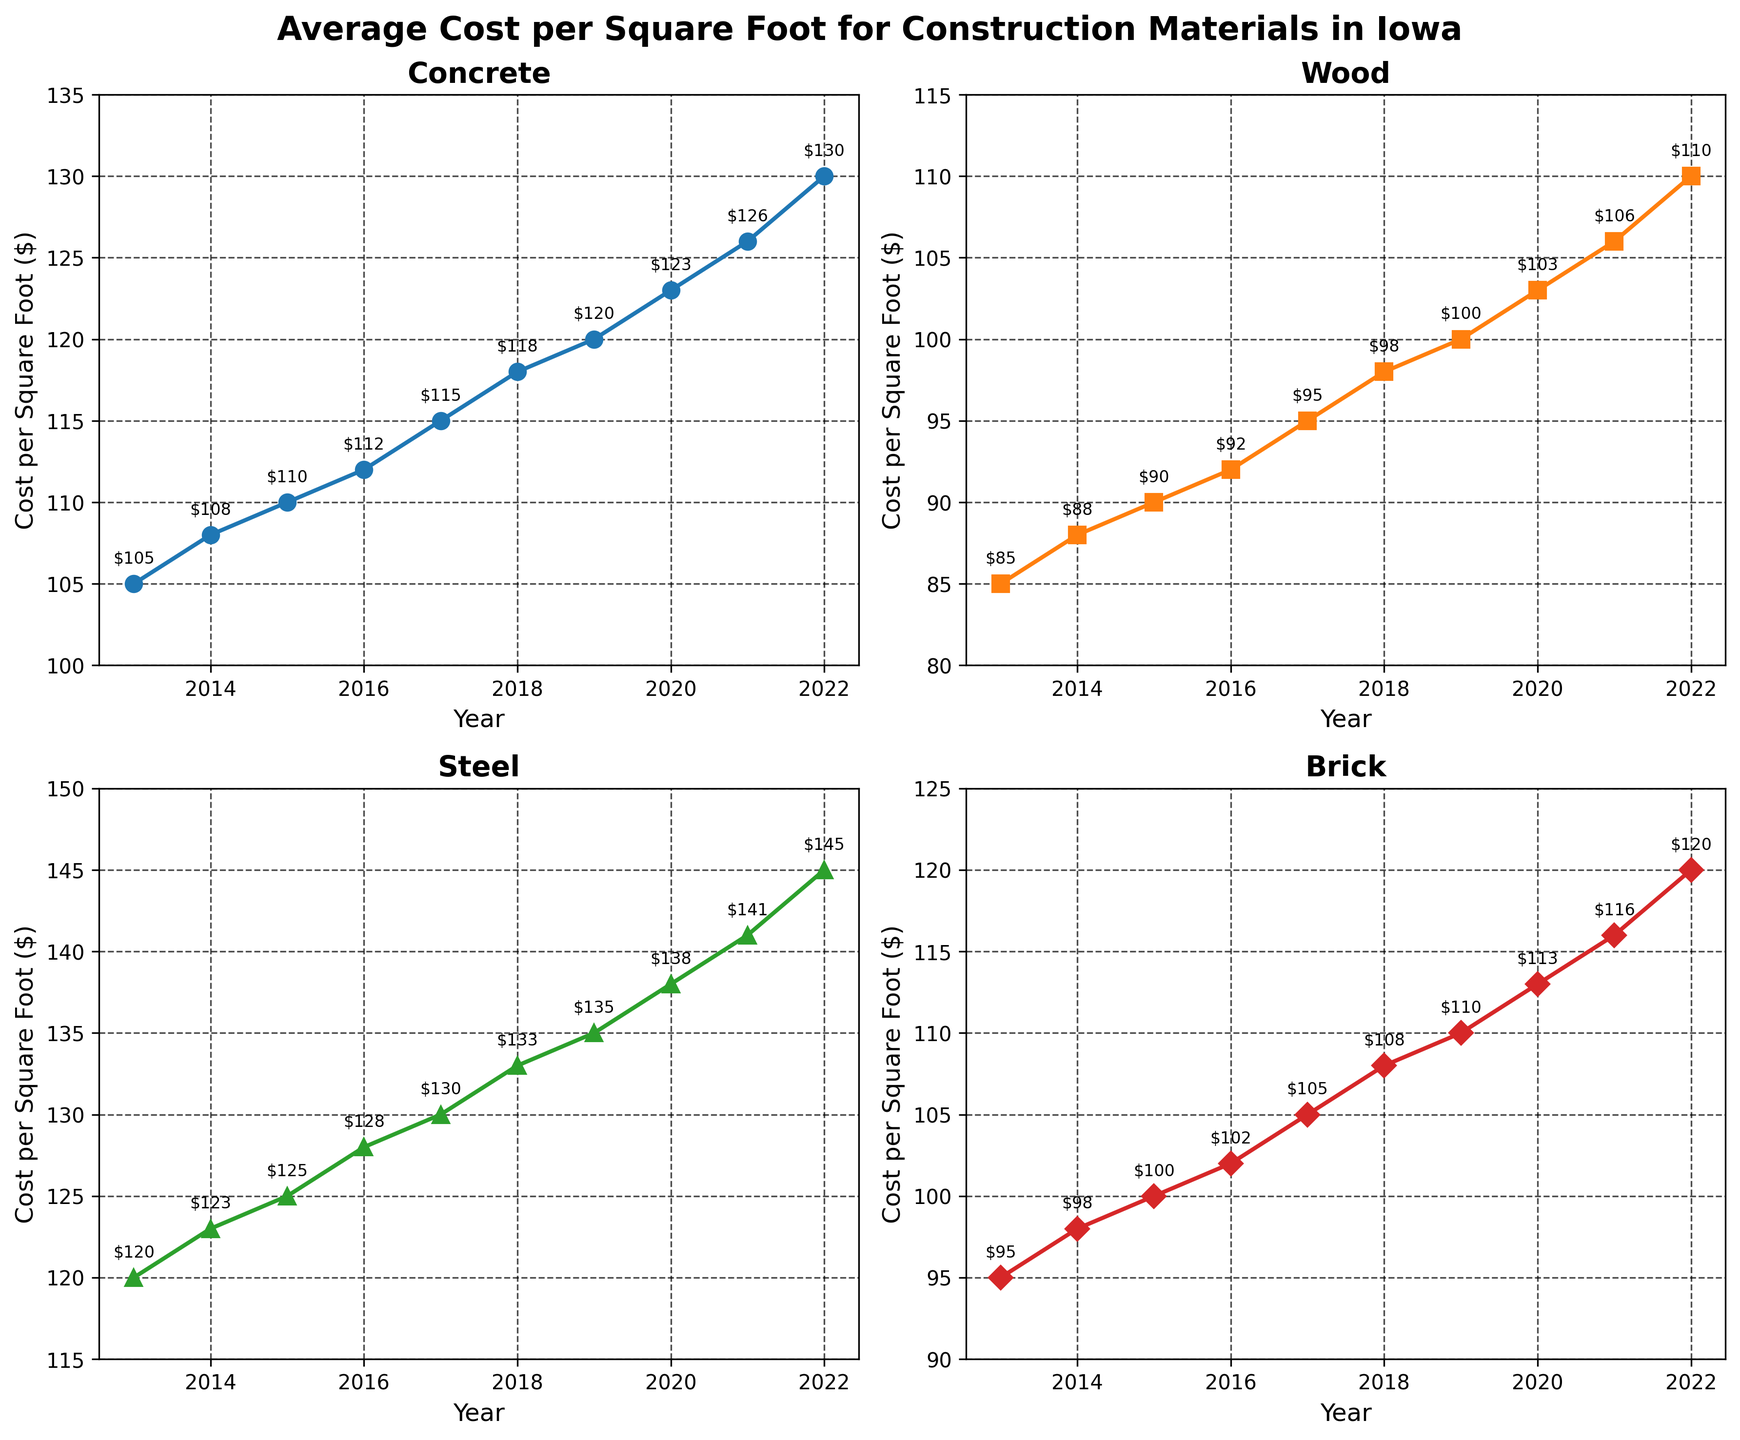Which material had the highest average cost per square foot in 2022? From the plot, compare the y-values for the year 2022 among all materials. Steel has the highest value.
Answer: Steel Which year saw the greatest increase in cost per square foot for Brick compared to the previous year? To find the year with the greatest increase, calculate the yearly differences for Brick: 2014: 3, 2015: 2, 2016: 2, 2017: 3, 2018: 3, 2019: 2, 2020: 3, 2021: 3, 2022: 4. The greatest increase occurred in 2022.
Answer: 2022 What's the overall trend for the average cost per square foot of Concrete from 2013 to 2022? Observing the plot for Concrete, the line shows a consistent upward trend from 2013 to 2022.
Answer: Upward trend Between Wood and Brick, which saw a faster increase in average cost per square foot from 2013 to 2018? Calculate the total increase for Wood (98-85=13) and Brick (108-95=13) over this period. Both increased at the same rate.
Answer: Same rate Is the cost per square foot for Steel in 2019 greater than that of Concrete in 2022? Compare the values for Steel in 2019 ($135) and Concrete in 2022 ($130) directly from the annotation on the plots. Steel in 2019 is higher.
Answer: Yes What is the average cost per square foot of Wood over the decade? Sum the yearly costs for Wood (85+88+90+92+95+98+100+103+106+110) and divide by the number of years (10). The sum is 967, so the average is 967/10 = 96.7.
Answer: 96.7 Which material showed the most gradual increase in cost per square foot over the 10 years? Look at the slopes of the lines for each material. Brick's increase appears the most gradual, with the least steep slope among the four.
Answer: Brick What was the total increase in cost per square foot for Steel from 2013 to 2022? Subtract the value of Steel in 2013 ($120) from the value in 2022 ($145). The total increase is 145 - 120 = 25.
Answer: 25 Did any material show a decrease in cost per square foot any year within the dataset? From the plot, observe each material line between consecutive years; all lines consistently rise without any dips, indicating there were no decreases.
Answer: No 